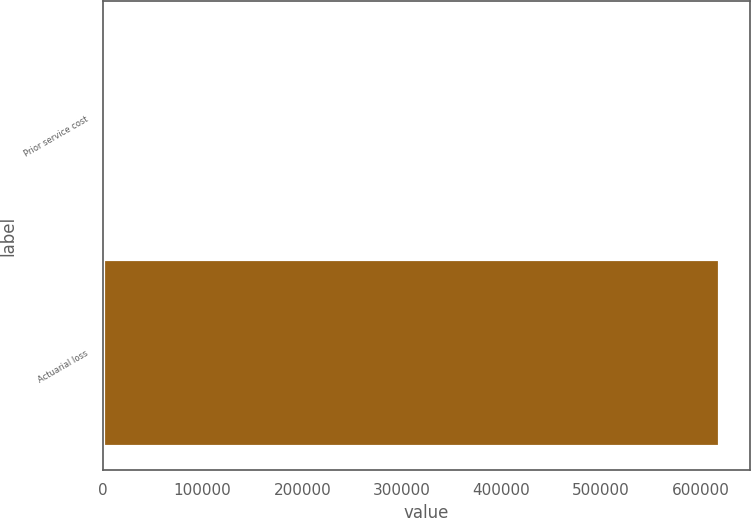Convert chart. <chart><loc_0><loc_0><loc_500><loc_500><bar_chart><fcel>Prior service cost<fcel>Actuarial loss<nl><fcel>163<fcel>618579<nl></chart> 